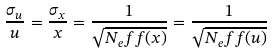<formula> <loc_0><loc_0><loc_500><loc_500>\frac { \sigma _ { u } } { u } = \frac { \sigma _ { x } } { x } = \frac { 1 } { \sqrt { N _ { e } f f ( x ) } } = \frac { 1 } { \sqrt { N _ { e } f f ( u ) } }</formula> 